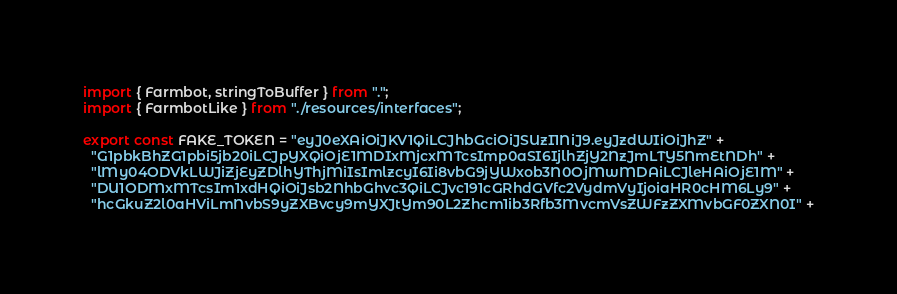<code> <loc_0><loc_0><loc_500><loc_500><_TypeScript_>import { Farmbot, stringToBuffer } from ".";
import { FarmbotLike } from "./resources/interfaces";

export const FAKE_TOKEN = "eyJ0eXAiOiJKV1QiLCJhbGciOiJSUzI1NiJ9.eyJzdWIiOiJhZ" +
  "G1pbkBhZG1pbi5jb20iLCJpYXQiOjE1MDIxMjcxMTcsImp0aSI6IjlhZjY2NzJmLTY5NmEtNDh" +
  "lMy04ODVkLWJiZjEyZDlhYThjMiIsImlzcyI6Ii8vbG9jYWxob3N0OjMwMDAiLCJleHAiOjE1M" +
  "DU1ODMxMTcsIm1xdHQiOiJsb2NhbGhvc3QiLCJvc191cGRhdGVfc2VydmVyIjoiaHR0cHM6Ly9" +
  "hcGkuZ2l0aHViLmNvbS9yZXBvcy9mYXJtYm90L2Zhcm1ib3Rfb3MvcmVsZWFzZXMvbGF0ZXN0I" +</code> 